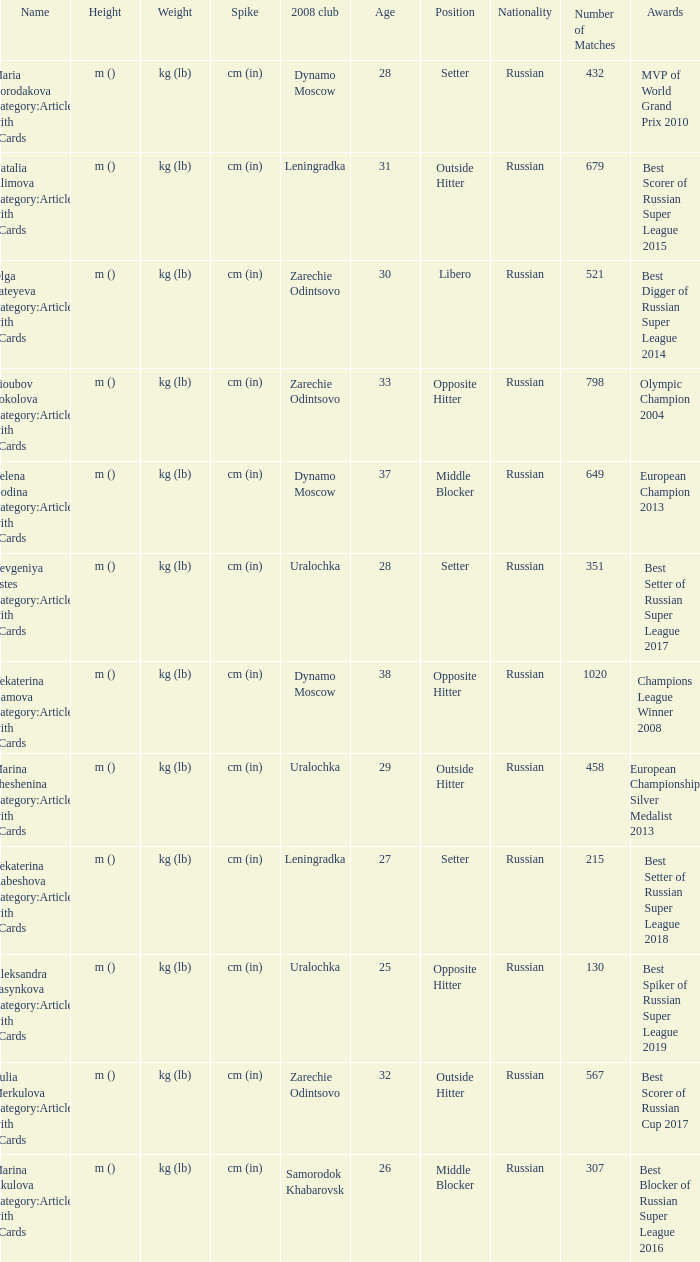What is the name when the 2008 club is uralochka? Yevgeniya Estes Category:Articles with hCards, Marina Sheshenina Category:Articles with hCards, Aleksandra Pasynkova Category:Articles with hCards. 